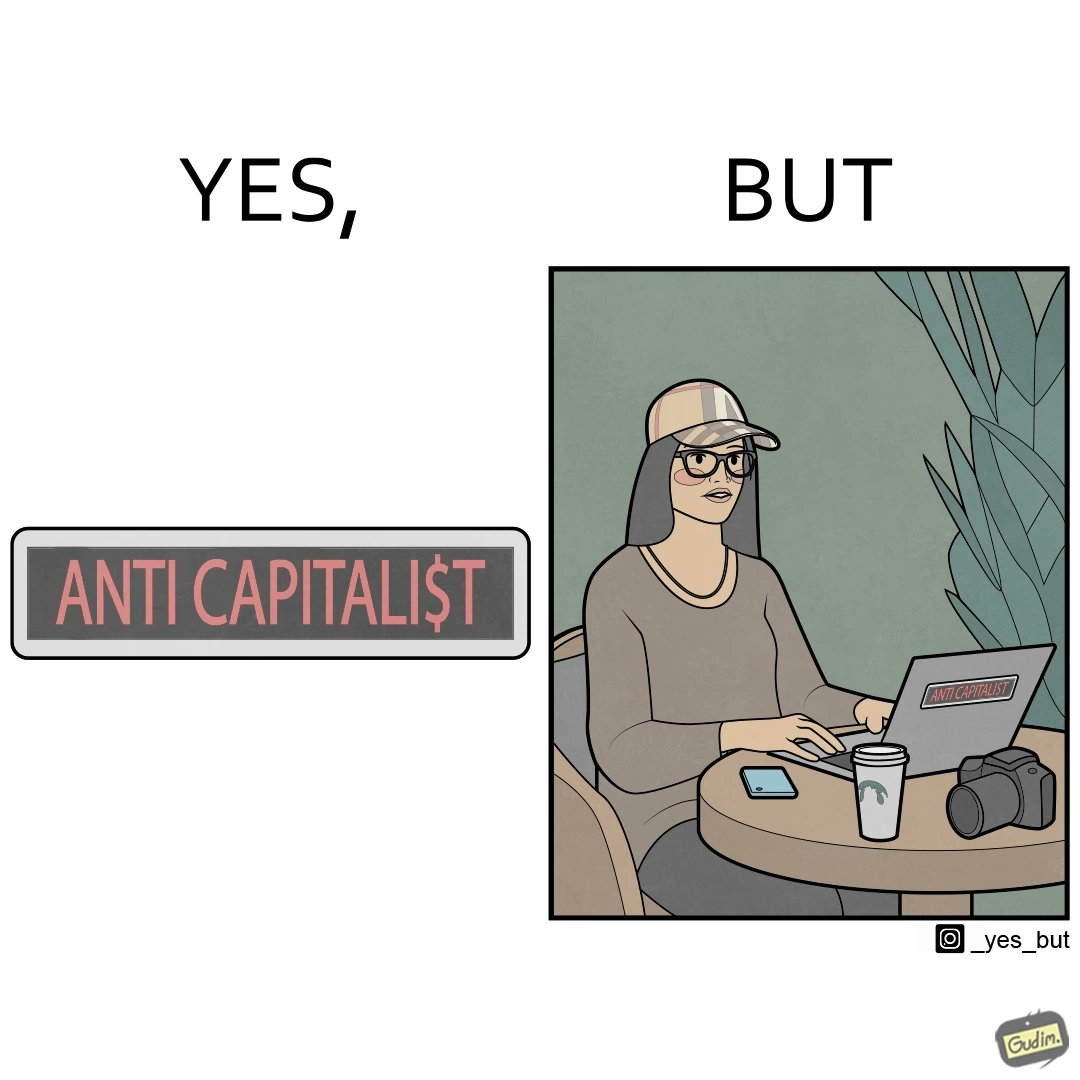What makes this image funny or satirical? The overall image is ironical because the people who claim to be anticapitalist are the ones with a lot of capital as shown here. While the woman supports anticapitalism as shown by the sticker on the back of her laptop, she has a phone, a camera and a laptop all of which require money. 